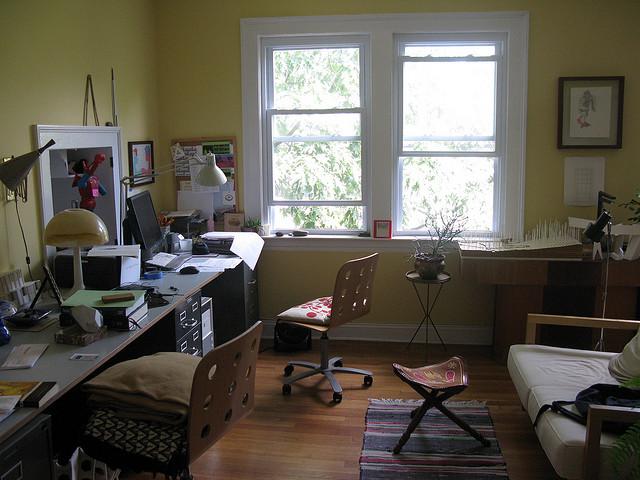Is this place clean?
Be succinct. Yes. Is this a bedroom?
Keep it brief. No. Is this an indoor scene?
Quick response, please. Yes. What room is this in?
Quick response, please. Office. Are there shades in both windows?
Write a very short answer. No. Why are there so many lamps in the room?
Write a very short answer. Light. 